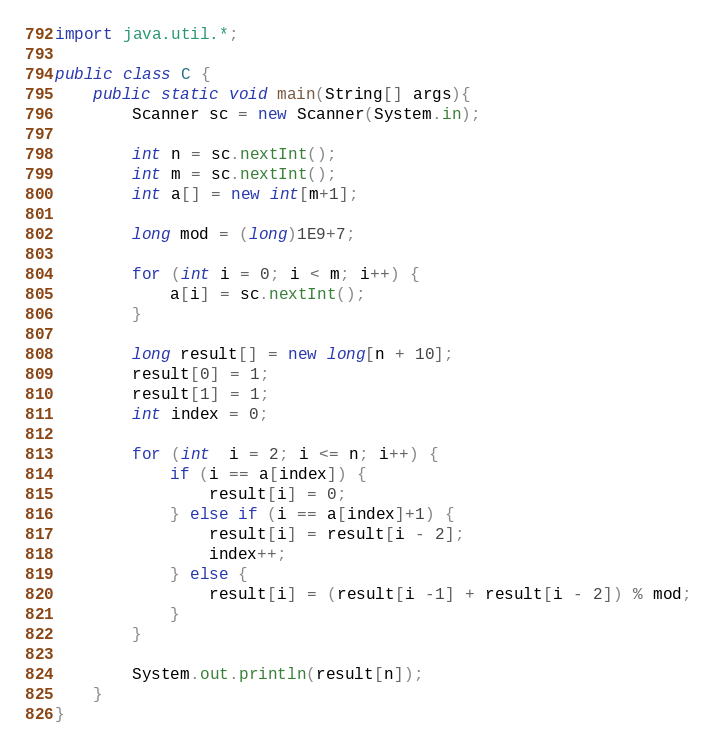Convert code to text. <code><loc_0><loc_0><loc_500><loc_500><_Java_>import java.util.*;

public class C {
	public static void main(String[] args){
        Scanner sc = new Scanner(System.in);
        
        int n = sc.nextInt();
        int m = sc.nextInt();
        int a[] = new int[m+1];

        long mod = (long)1E9+7;

        for (int i = 0; i < m; i++) {
            a[i] = sc.nextInt();
        }

        long result[] = new long[n + 10];
        result[0] = 1;
        result[1] = 1;
        int index = 0;

        for (int  i = 2; i <= n; i++) {
            if (i == a[index]) {
                result[i] = 0;
            } else if (i == a[index]+1) {
                result[i] = result[i - 2];
                index++;
            } else {
                result[i] = (result[i -1] + result[i - 2]) % mod;
            }
        }

        System.out.println(result[n]);
	}
}</code> 